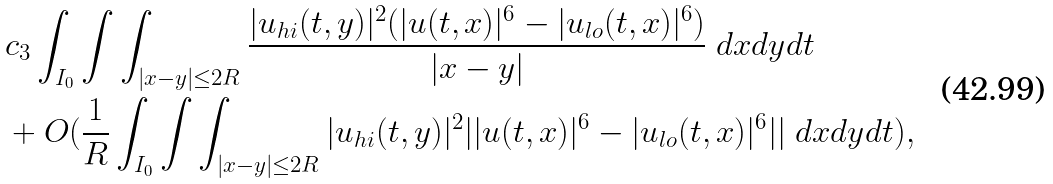<formula> <loc_0><loc_0><loc_500><loc_500>& c _ { 3 } \int _ { I _ { 0 } } \int \int _ { | x - y | \leq 2 R } \frac { | u _ { h i } ( t , y ) | ^ { 2 } ( | u ( t , x ) | ^ { 6 } - | u _ { l o } ( t , x ) | ^ { 6 } ) } { | x - y | } \ d x d y d t \\ & + O ( \frac { 1 } { R } \int _ { I _ { 0 } } \int \int _ { | x - y | \leq 2 R } | u _ { h i } ( t , y ) | ^ { 2 } | | u ( t , x ) | ^ { 6 } - | u _ { l o } ( t , x ) | ^ { 6 } | | \ d x d y d t ) ,</formula> 